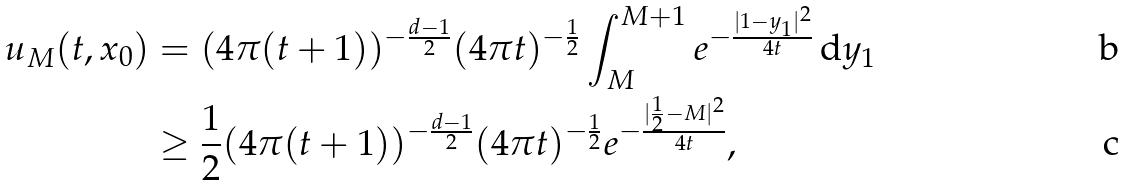Convert formula to latex. <formula><loc_0><loc_0><loc_500><loc_500>u _ { M } ( t , x _ { 0 } ) & = ( 4 \pi ( t + 1 ) ) ^ { - \frac { d - 1 } { 2 } } ( 4 \pi t ) ^ { - \frac { 1 } { 2 } } \int _ { M } ^ { M + 1 } e ^ { - \frac { | 1 - y _ { 1 } | ^ { 2 } } { 4 t } } \, \mathrm d y _ { 1 } \\ & \geq \frac { 1 } { 2 } ( 4 \pi ( t + 1 ) ) ^ { - \frac { d - 1 } { 2 } } ( 4 \pi t ) ^ { - \frac { 1 } { 2 } } e ^ { - \frac { | \frac { 1 } { 2 } - M | ^ { 2 } } { 4 t } } ,</formula> 